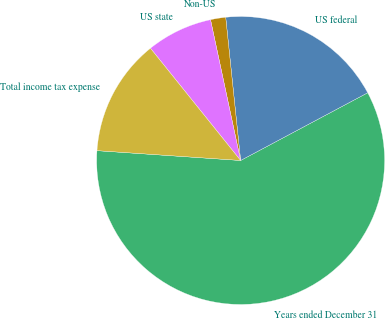Convert chart. <chart><loc_0><loc_0><loc_500><loc_500><pie_chart><fcel>Years ended December 31<fcel>US federal<fcel>Non-US<fcel>US state<fcel>Total income tax expense<nl><fcel>58.88%<fcel>18.86%<fcel>1.7%<fcel>7.42%<fcel>13.14%<nl></chart> 